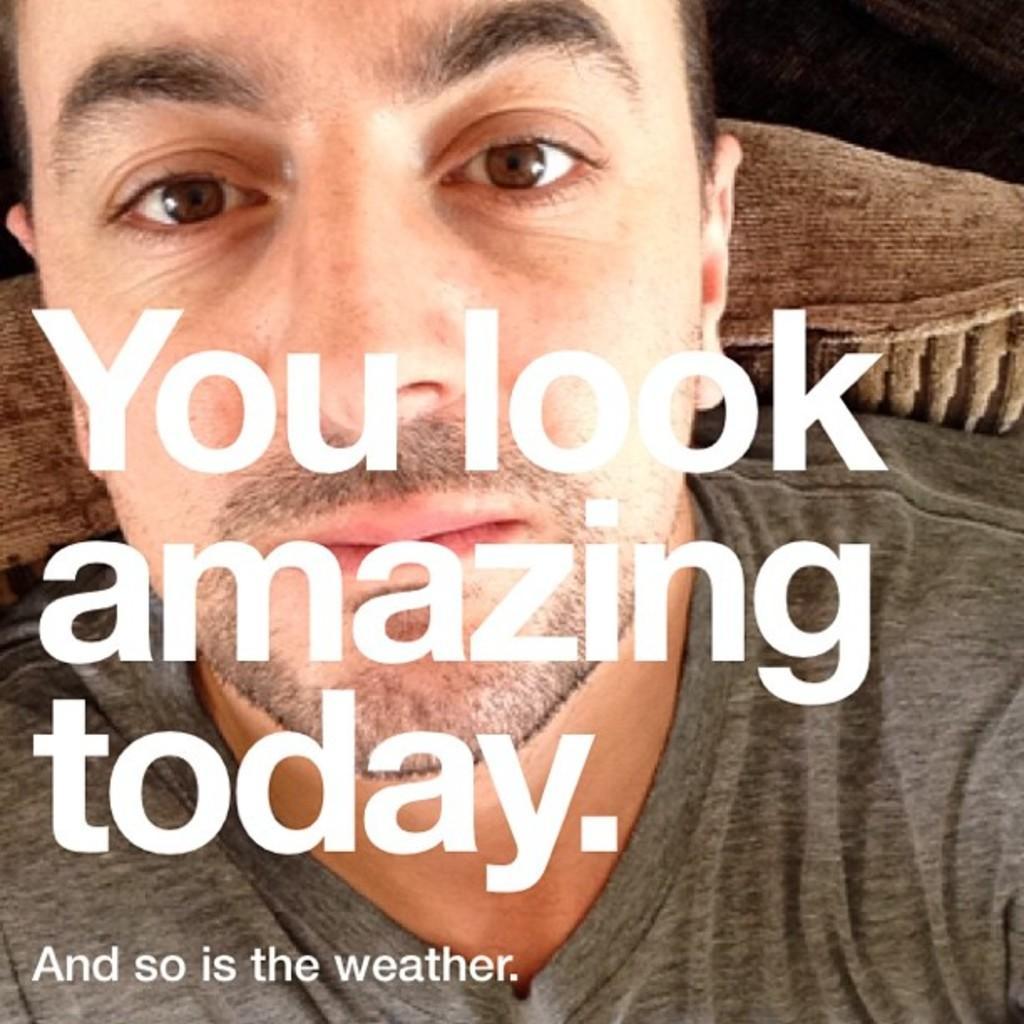How would you summarize this image in a sentence or two? This image consists of a poster with an image of a man sitting on the couch and there is a text on it. 